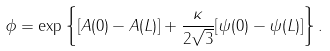<formula> <loc_0><loc_0><loc_500><loc_500>\phi = \exp \left \{ [ A ( 0 ) - A ( L ) ] + \frac { \kappa } { 2 \sqrt { 3 } } [ \psi ( 0 ) - \psi ( L ) ] \right \} .</formula> 